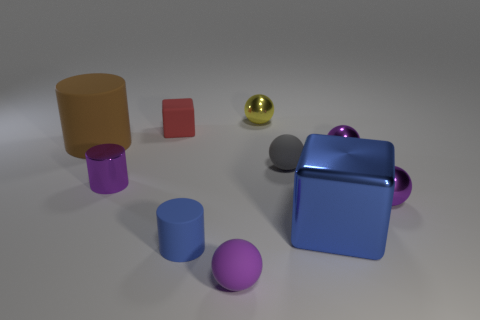Is there any other thing that is the same color as the small matte cylinder?
Your response must be concise. Yes. Is the shape of the small purple shiny thing that is to the left of the blue rubber thing the same as  the blue rubber object?
Provide a succinct answer. Yes. How many things are yellow metal spheres or small purple metallic objects that are on the right side of the gray matte ball?
Offer a terse response. 3. Are there more metallic cylinders that are behind the small gray matte object than big yellow metallic cubes?
Your response must be concise. No. Are there the same number of small purple matte things behind the blue matte cylinder and yellow balls that are right of the rubber block?
Offer a terse response. No. There is a small rubber ball that is in front of the blue metallic thing; are there any metal objects left of it?
Make the answer very short. Yes. What is the shape of the yellow thing?
Provide a short and direct response. Sphere. There is a cube that is the same color as the small rubber cylinder; what is its size?
Offer a terse response. Large. There is a cylinder that is behind the purple ball behind the small metal cylinder; what size is it?
Your answer should be compact. Large. What is the size of the cube right of the small gray matte sphere?
Make the answer very short. Large. 